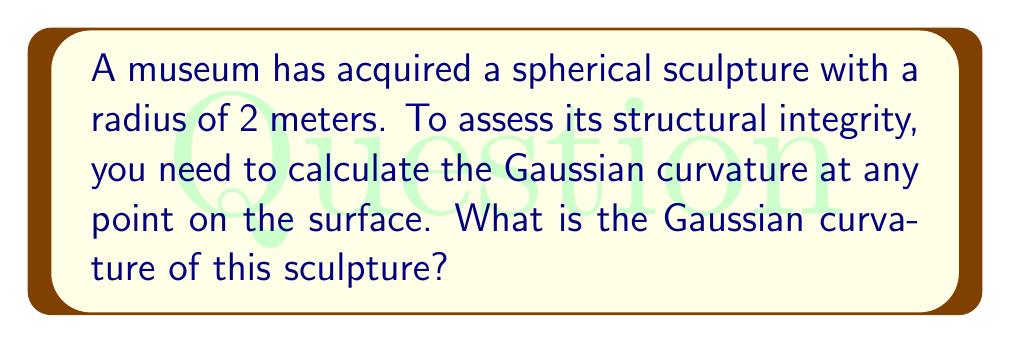Could you help me with this problem? To solve this problem, we'll follow these steps:

1. Recall the formula for Gaussian curvature of a sphere:
   For a sphere with radius $r$, the Gaussian curvature $K$ is given by:
   
   $$K = \frac{1}{r^2}$$

2. In this case, we're given that the radius $r = 2$ meters.

3. Substitute the radius into the formula:
   
   $$K = \frac{1}{(2\text{ m})^2} = \frac{1}{4\text{ m}^2}$$

4. Simplify:
   
   $$K = 0.25\text{ m}^{-2}$$

Note: The Gaussian curvature is constant for all points on a sphere, which is why we don't need to specify a particular point on the surface.

This value indicates that the sculpture has a positive, constant curvature throughout its surface, which is characteristic of spheres. A conservator can use this information to assess the structural integrity of the sculpture, as any deviations from this expected curvature might indicate areas of stress or damage.
Answer: $0.25\text{ m}^{-2}$ 